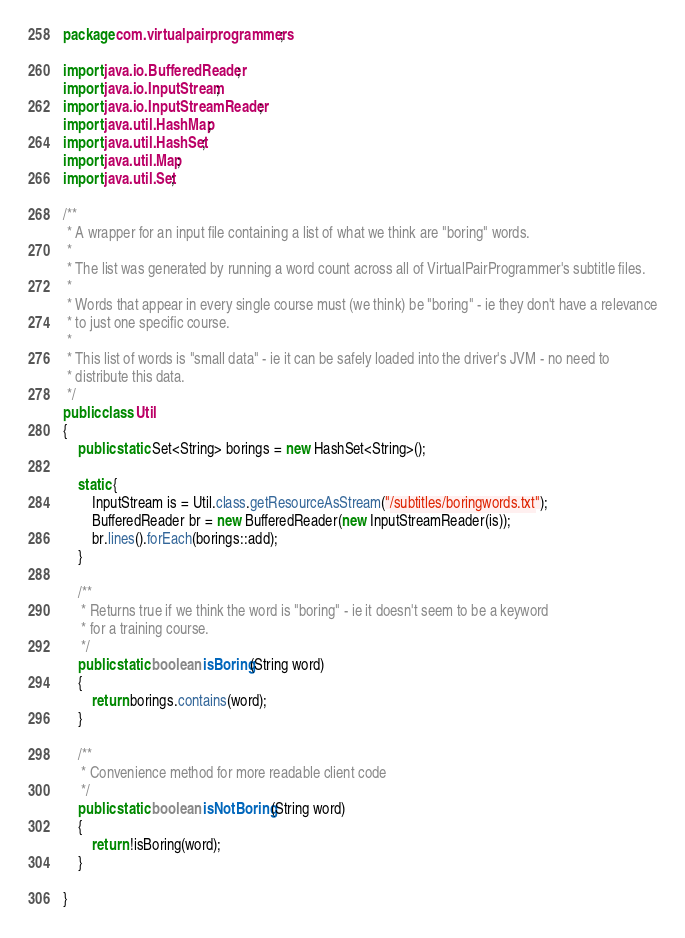Convert code to text. <code><loc_0><loc_0><loc_500><loc_500><_Java_>package com.virtualpairprogrammers;

import java.io.BufferedReader;
import java.io.InputStream;
import java.io.InputStreamReader;
import java.util.HashMap;
import java.util.HashSet;
import java.util.Map;
import java.util.Set;

/**
 * A wrapper for an input file containing a list of what we think are "boring" words.
 * 
 * The list was generated by running a word count across all of VirtualPairProgrammer's subtitle files.
 * 
 * Words that appear in every single course must (we think) be "boring" - ie they don't have a relevance
 * to just one specific course.
 * 
 * This list of words is "small data" - ie it can be safely loaded into the driver's JVM - no need to 
 * distribute this data.
 */
public class Util 
{
	public static Set<String> borings = new HashSet<String>();
	
	static {
		InputStream is = Util.class.getResourceAsStream("/subtitles/boringwords.txt");
		BufferedReader br = new BufferedReader(new InputStreamReader(is));
		br.lines().forEach(borings::add);
	}

	/**
	 * Returns true if we think the word is "boring" - ie it doesn't seem to be a keyword
	 * for a training course.
	 */
	public static boolean isBoring(String word)
	{
		return borings.contains(word);
	}

	/**
	 * Convenience method for more readable client code
	 */
	public static boolean isNotBoring(String word)
	{
		return !isBoring(word);
	}
	
}
</code> 